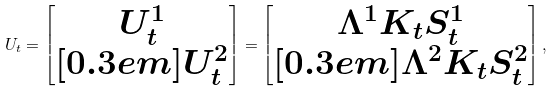Convert formula to latex. <formula><loc_0><loc_0><loc_500><loc_500>U _ { t } = \begin{bmatrix} U ^ { 1 } _ { t } \\ [ 0 . 3 e m ] U ^ { 2 } _ { t } \end{bmatrix} = \begin{bmatrix} \Lambda ^ { 1 } K _ { t } S _ { t } ^ { 1 } \\ [ 0 . 3 e m ] \Lambda ^ { 2 } K _ { t } S _ { t } ^ { 2 } \end{bmatrix} ,</formula> 